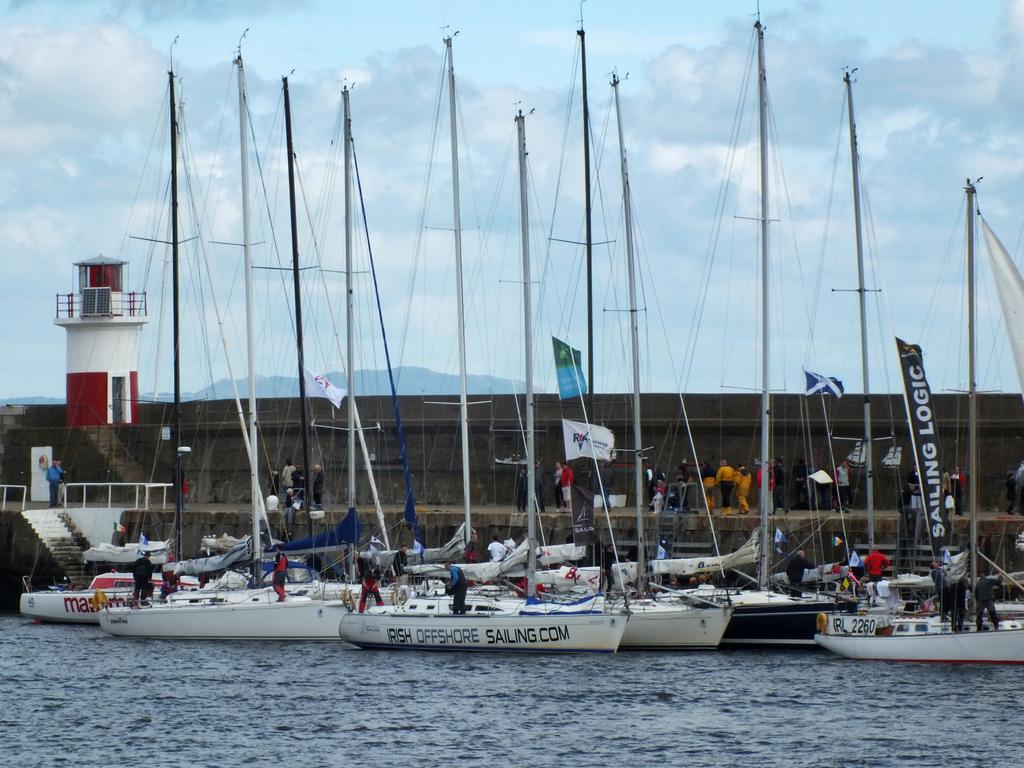What is written vertically on the black banner?
Your response must be concise. Sailing logic. 